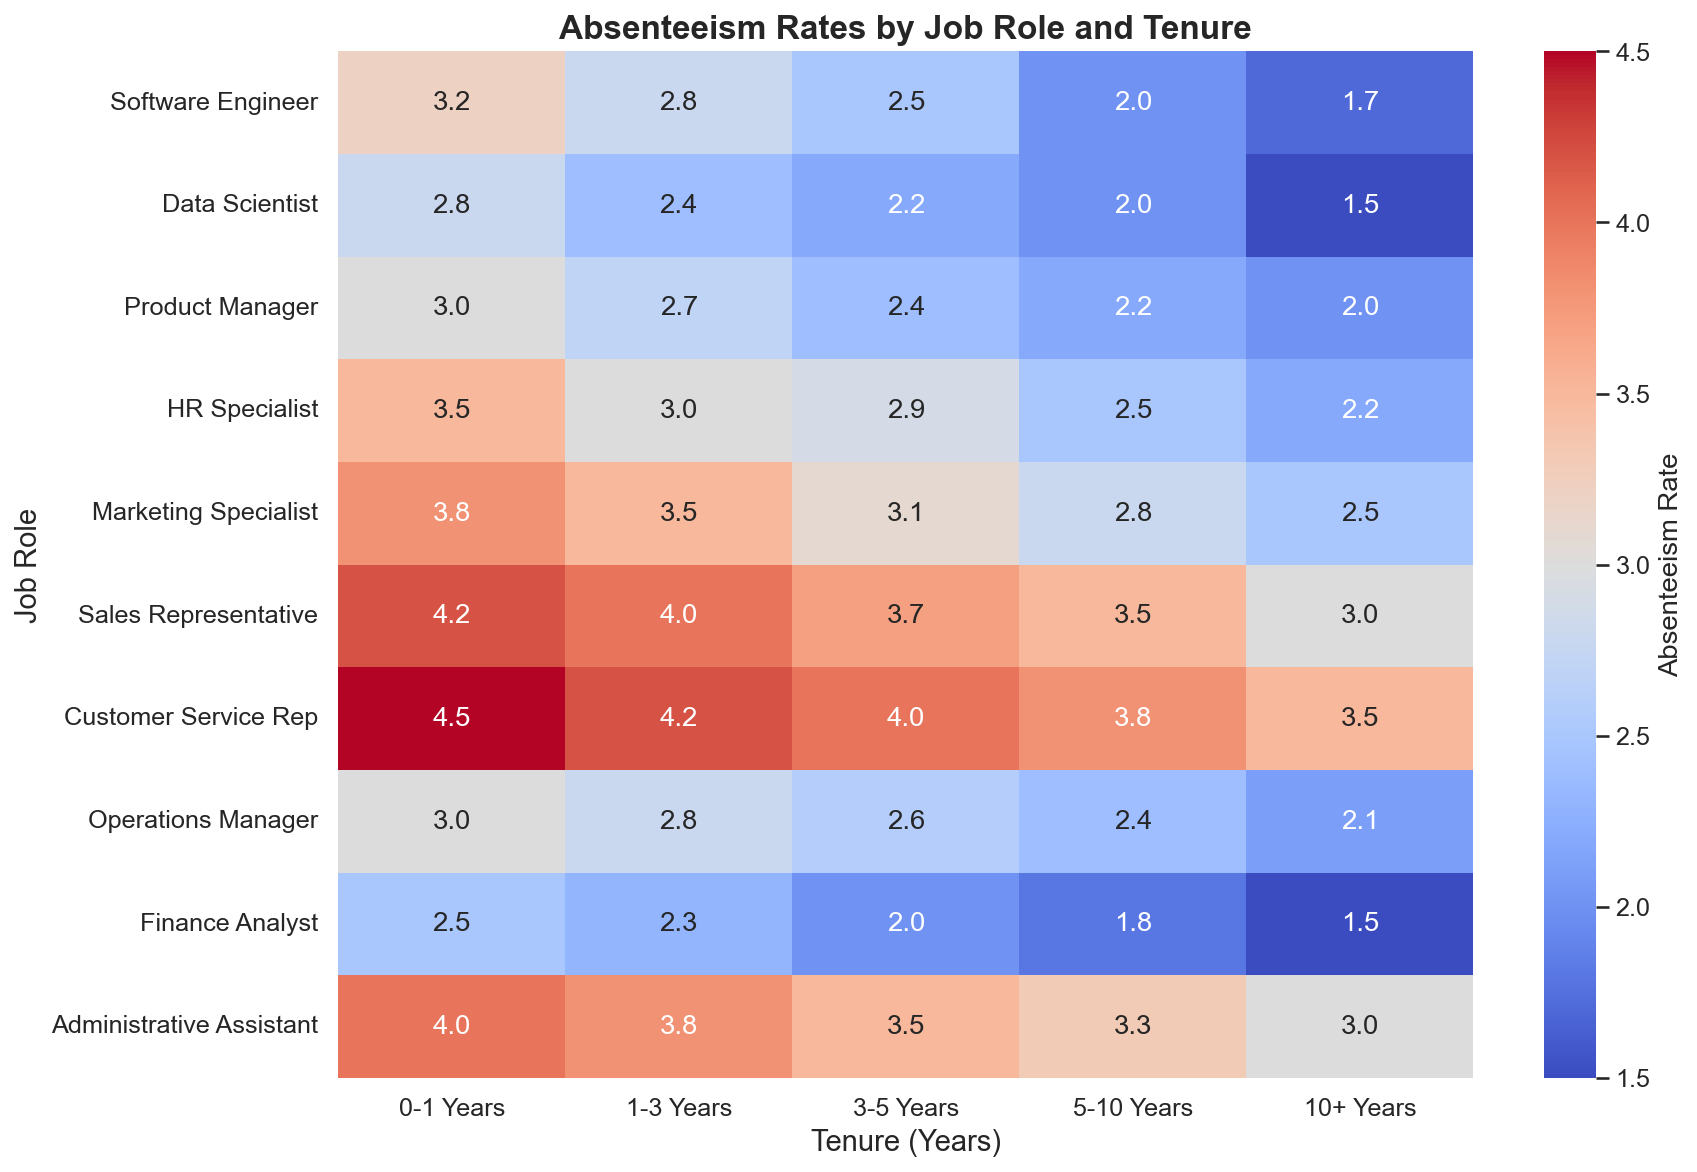What's the absenteeism rate for a Data Scientist with 3-5 years of tenure? To find the absenteeism rate for a Data Scientist with 3-5 years of tenure, locate the 'Data Scientist' row and the '3-5 Years' column in the heatmap.
Answer: 2.2 Which job role has the highest absenteeism rate for the first year of tenure? Compare the absenteeism rates in the '0-1 Years' column for all job roles. The highest value corresponds to the job role with the highest absenteeism rate.
Answer: Customer Service Rep What is the average absenteeism rate for a Software Engineer across all tenure ranges? Sum the values in the 'Software Engineer' row and divide by the number of values. (3.2 + 2.8 + 2.5 + 2.0 + 1.7) / 5 = 12.2 / 5 = 2.44
Answer: 2.44 How does the absenteeism rate for an Administrative Assistant with 5-10 years of tenure compare to that of a Customer Service Rep with the same tenure? Look at the 'Administrative Assistant' row under '5-10 Years' and the 'Customer Service Rep' row under '5-10 Years' to compare the values. Administrative Assistant: 3.3, Customer Service Rep: 3.8. 3.3 is less than 3.8
Answer: Administrative Assistant has a lower rate Which job role shows the most significant decrease in absenteeism rate from 0-1 years to 10+ years? For each job role, subtract the '10+ Years' value from the '0-1 Years' value. The job role with the highest difference has the most significant decrease.
Answer: Customer Service Rep What is the overall trend of absenteeism rates by tenure for the role of Marketing Specialist? Track the values in the 'Marketing Specialist' row across the tenure columns from '0-1 Years' to '10+ Years.' The values decrease continuously.
Answer: It decreases Which tenure group has the highest average absenteeism rate across all job roles? Calculate the average of each tenure column and compare. (Sum each column's values and divide by the number of roles). '0-1 Years' has the highest average.
Answer: 0-1 Years What is the difference in absenteeism rate between a Finance Analyst and an Operations Manager with 1-3 years of tenure? Subtract the '1-3 Years' absenteeism rate of Operations Manager from that of Finance Analyst. 2.3 - 2.8 = -0.5
Answer: -0.5 Which job role has the least variation in absenteeism rates across all tenure periods? Calculate the range for each job role (difference between highest and lowest values) and find the smallest range. Data Scientist has values within 1.3 (smallest range).
Answer: Data Scientist 